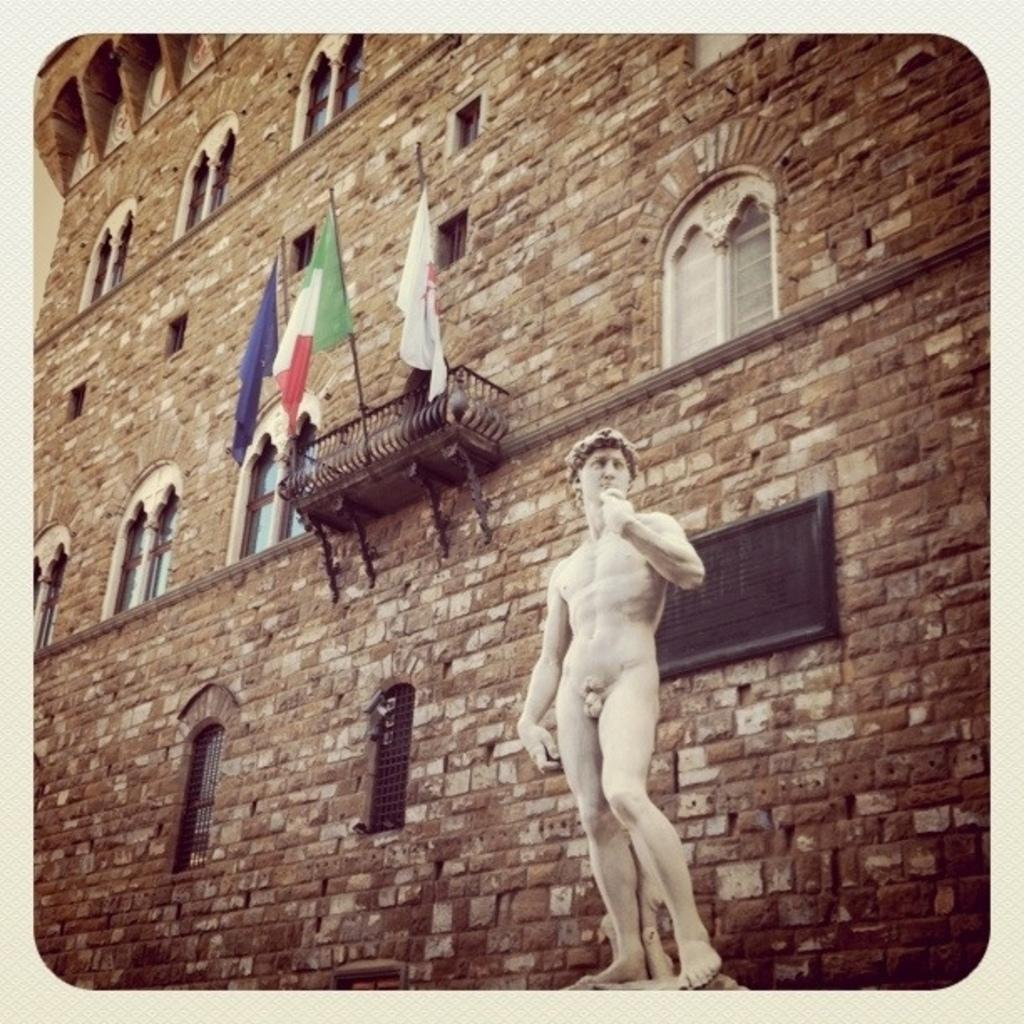What is the main subject in the front of the image? There is a statue in the front of the image. What can be seen in the background of the image? There is a building in the background of the image. How many flags are visible in the image? There are three flags in the image. What architectural feature can be seen on the building? There are windows visible on the building. What type of nut is being given as advice in the image? There is no nut or advice present in the image. 